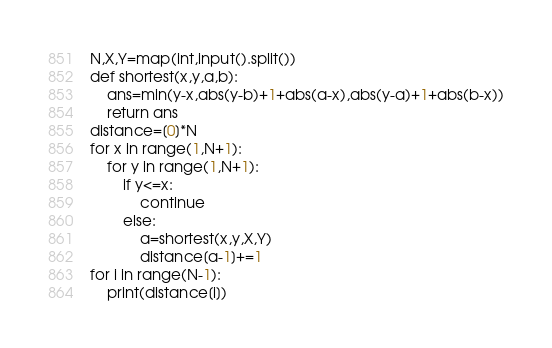<code> <loc_0><loc_0><loc_500><loc_500><_Python_>N,X,Y=map(int,input().split())
def shortest(x,y,a,b):
    ans=min(y-x,abs(y-b)+1+abs(a-x),abs(y-a)+1+abs(b-x))
    return ans
distance=[0]*N
for x in range(1,N+1):
    for y in range(1,N+1):
        if y<=x:
            continue
        else:
            a=shortest(x,y,X,Y)
            distance[a-1]+=1
for i in range(N-1):
    print(distance[i])</code> 